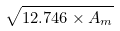<formula> <loc_0><loc_0><loc_500><loc_500>\sqrt { 1 2 . 7 4 6 \times A _ { m } }</formula> 